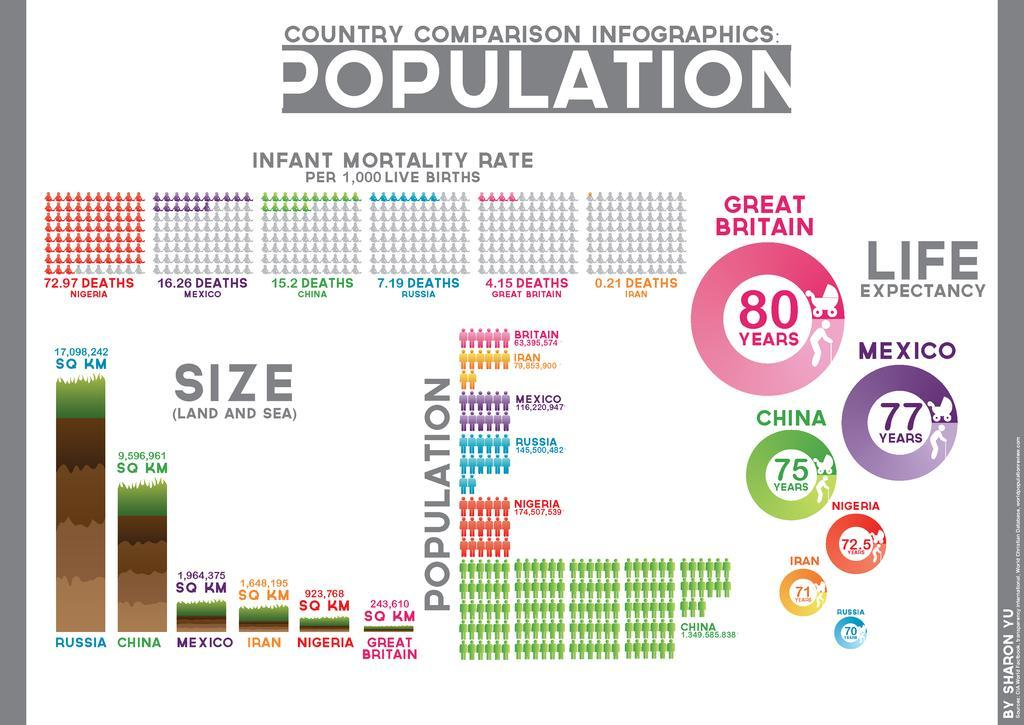Which country has the second-highest infant mortality rate?
Answer the question with a short phrase. Mexico Which country has the third-highest population? Russia Which color used to represent Mexico-pink, green, violet, red? violet Which country has the second-highest life expectancy? Mexico Which country has the second-smallest infant mortality rate? Great Britain Which country has the second-largest land area? China Which country has the second-smallest population? Iran Which color used to represent Russia-pink, green, blue, red? blue Which country has the second-smallest life expectancy? Iran Which country has the second-smallest land area? Nigeria 